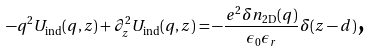Convert formula to latex. <formula><loc_0><loc_0><loc_500><loc_500>- q ^ { 2 } U _ { \text {ind} } ( q , z ) + \partial _ { z } ^ { 2 } U _ { \text {ind} } ( q , z ) = - \frac { e ^ { 2 } \delta n _ { \text {2D} } ( q ) } { \epsilon _ { 0 } \epsilon _ { r } } \delta ( z - d ) \text {,}</formula> 